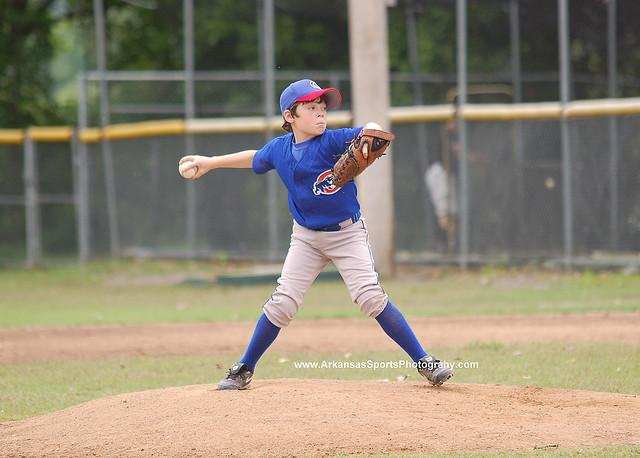Where does the URL text actually exist?

Choices:
A) on boy
B) on grass
C) on shoe
D) image file image file 